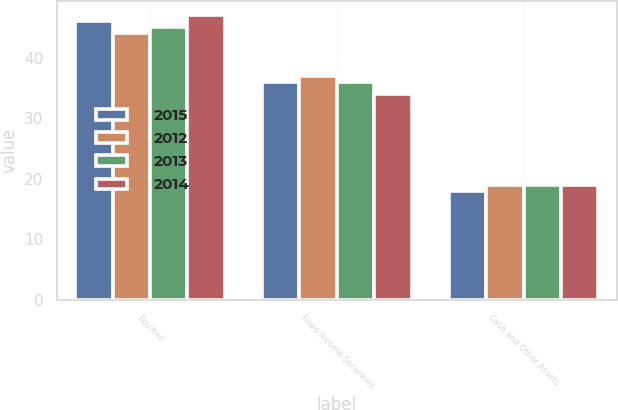Convert chart to OTSL. <chart><loc_0><loc_0><loc_500><loc_500><stacked_bar_chart><ecel><fcel>Equities<fcel>Fixed Income Securities<fcel>Cash and Other Assets<nl><fcel>2015<fcel>46<fcel>36<fcel>18<nl><fcel>2012<fcel>44<fcel>37<fcel>19<nl><fcel>2013<fcel>45<fcel>36<fcel>19<nl><fcel>2014<fcel>47<fcel>34<fcel>19<nl></chart> 